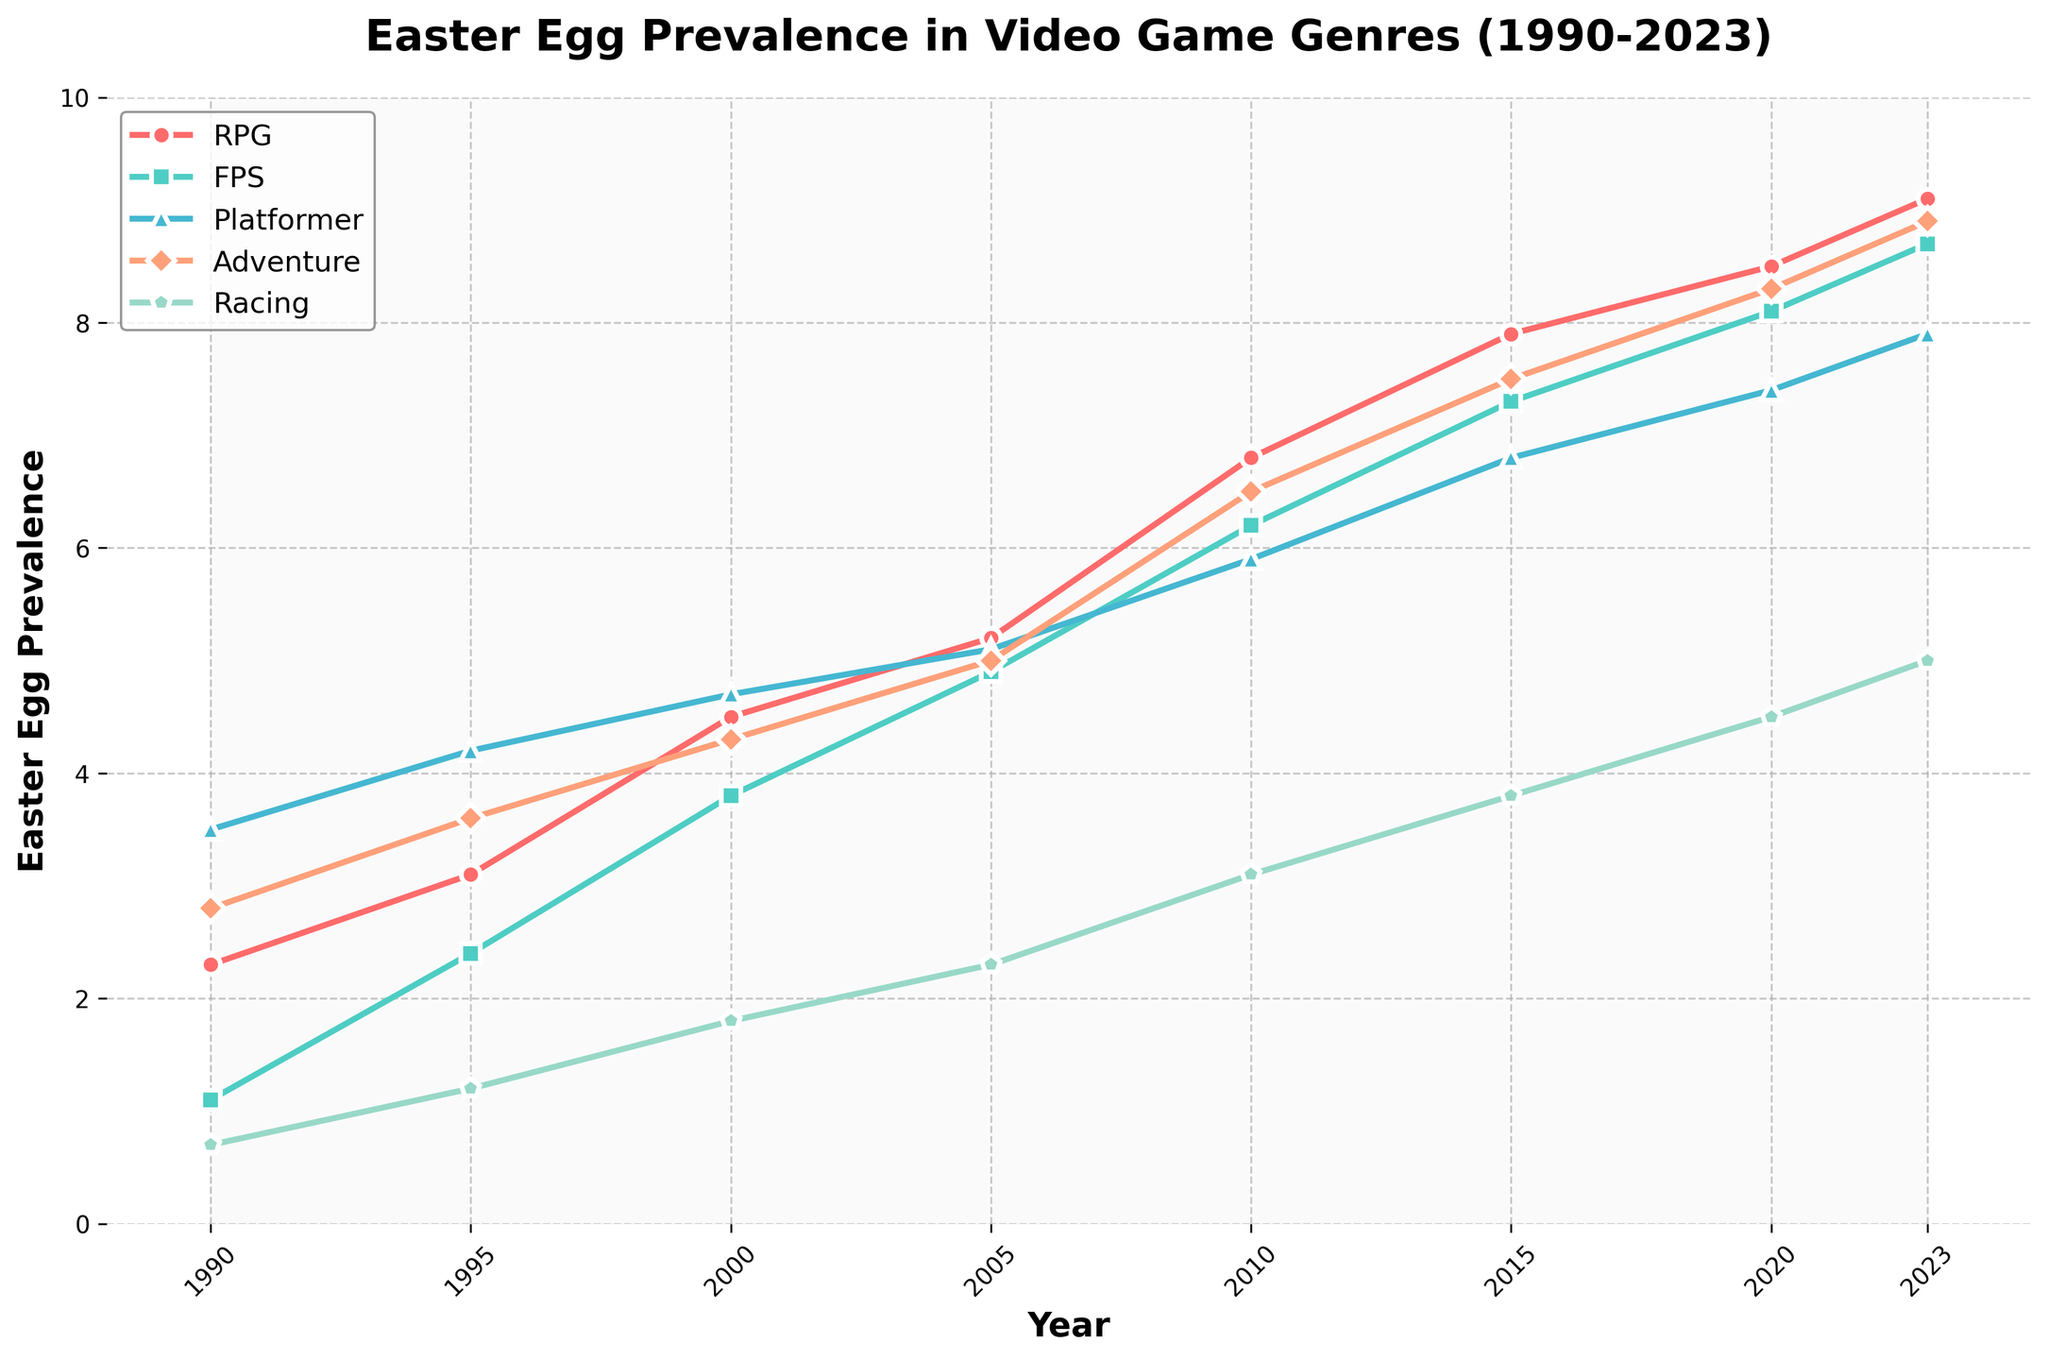What genre had the highest prevalence of easter eggs in 2023? From the figure, look at the lines corresponding to each genre at the year 2023 and identify the highest value. RPG has the highest prevalence with a value of 9.1.
Answer: RPG Which genre showed the most steady increase in easter egg prevalence from 1990 to 2023? Observe the lines for each genre from 1990 to 2023. The RPG genre shows a consistent upward trend without any significant dips, indicating a steady increase.
Answer: RPG In what year did the FPS genre surpass the Platformer genre in easter egg prevalence? Compare the lines for FPS and Platformer year by year. FPS surpassed Platformer in the year 2005.
Answer: 2005 Compare the easter egg prevalence in the RPG and Racing genres in the year 2000. What is the difference? Identify the values for RPG and Racing in the year 2000 from the figure. RPG has 4.5 and Racing has 1.8. The difference is 4.5 - 1.8 = 2.7.
Answer: 2.7 What is the average easter egg prevalence for the Adventure genre from 1990 to 2023? Sum up the Adventure genre values and divide by the number of years (8): (2.8 + 3.6 + 4.3 + 5.0 + 6.5 + 7.5 + 8.3 + 8.9) / 8 = 5.9875, approximately 6.0
Answer: 6.0 Which genre had the smallest increase in easter egg prevalence from 1990 to 2023? Calculate the difference in values from 1990 to 2023 for each genre. Racing shows an increase from 0.7 to 5.0, which is the smallest increase compared to other genres.
Answer: Racing From 1990 to 2023, which two genres had the closest prevalence in the year 2015? Compare the values of each genre in 2015. Platformer and Racing have 6.8 and 3.8, respectively, but Adventure and Platformer have closer values of 7.5 and 6.8. The closest gap is between Adventure and Platformer with a difference of 0.7.
Answer: Adventure and Platformer What is the median easter egg prevalence value for the Platformer genre between 1990 and 2023? Organize the values of the Platformer genre in ascending order: (3.5, 4.2, 4.7, 5.1, 5.9, 6.8, 7.4, 7.9). With 8 values, the median is the average of the 4th and 5th values: (5.1 + 5.9) / 2 = 5.5.
Answer: 5.5 Between 1990 and 2023, which year saw the Racing genre have an easter egg prevalence value of 1.2? Look at the Racing genre line to identify the year with a value of 1.2. This occurs in 1995.
Answer: 1995 Which genre experienced the highest increase in easter egg prevalence from 2000 to 2010? Calculate the difference in values from 2000 to 2010 for each genre. RPG went from 4.5 to 6.8, which is an increase of 2.3, the highest among all genres.
Answer: RPG 